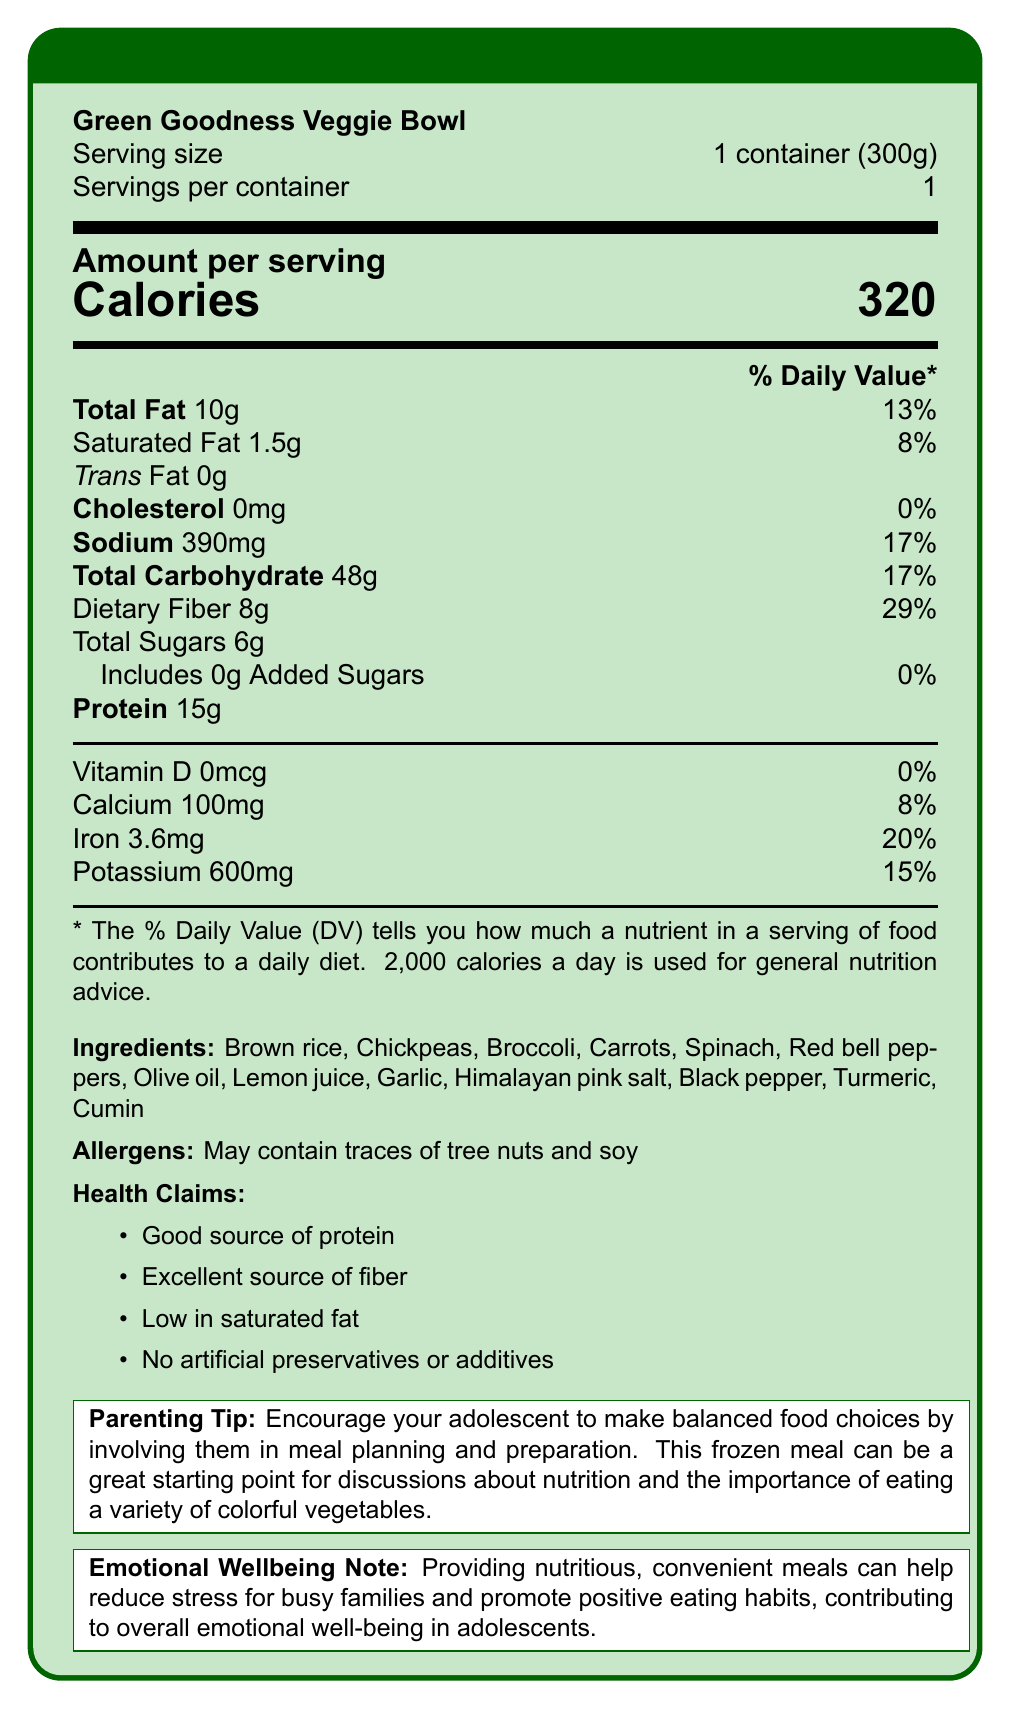what is the serving size? The serving size is provided at the beginning of the document under the "Serving size" section.
Answer: 1 container (300g) how many calories are in one serving? The calorie count is prominently displayed under the "Amount per serving" section.
Answer: 320 calories what percentage of the daily value of sodium does one serving contain? This information is located next to the sodium content in the list of nutritional values.
Answer: 17% how much protein is in one serving? The protein amount is listed in the nutrition facts under "Protein".
Answer: 15g what are the primary ingredients in this meal? The ingredients are listed towards the bottom of the document.
Answer: Brown rice, Chickpeas, Broccoli, Carrots, Spinach, Red bell peppers, Olive oil, Lemon juice, Garlic, Himalayan pink salt, Black pepper, Turmeric, Cumin which of the following nutrients is not present in this vegetarian meal? A. Vitamin D B. Iron C. Potassium D. Calcium The nutrition facts show that Vitamin D is 0mcg, meaning it is not present, whereas other nutrients like Iron, Potassium, and Calcium are present with specific amounts.
Answer: A. Vitamin D how much dietary fiber does the meal provide? A. 5g B. 8g C. 10g D. 15g The nutrition facts state that the meal contains 8g of dietary fiber.
Answer: B. 8g is this meal suitable for someone avoiding cholesterol? The document shows that the cholesterol content is 0mg.
Answer: Yes summarize the main idea of this document. This summary covers the key nutritional information, ingredients, and the general purpose of the meal as outlined in the document, aiming to support busy families in providing a healthy meal.
Answer: The Green Goodness Veggie Bowl provides a balanced meal option with low sodium content and a good source of protein and fiber. It includes various vegetables and natural ingredients, suitable for busy families and promotes positive eating habits among adolescents. are there any artificial preservatives or additives in this meal? The document lists "No artificial preservatives or additives" under the health claims section.
Answer: No what are the possible allergens listed for the meal? Possible allergens mentioned in the document include traces of tree nuts and soy.
Answer: Tree nuts and soy can you tell from the document if the veggies are organic? The document does not provide any information on whether the vegetables used are organic.
Answer: Cannot be determined what is the total fat content and its corresponding daily value percentage? The total fat content is 10g, which is 13% of the daily value, as shown in the nutrition facts.
Answer: 10g, 13% what is the primary target audience for this meal based on parenting tips and emotional well-being note? The parenting tip and emotional well-being note focus on busy families and adolescents, highlighting convenience and positive eating habits.
Answer: Busy families and adolescents 